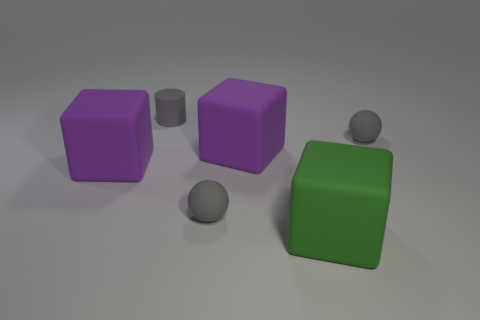Are the small ball that is on the left side of the big green thing and the green cube made of the same material?
Give a very brief answer. Yes. What is the material of the large purple thing that is right of the matte cube that is to the left of the small gray rubber cylinder?
Give a very brief answer. Rubber. What number of small rubber things have the same shape as the big green object?
Provide a short and direct response. 0. There is a gray rubber ball that is to the left of the cube that is right of the big purple object to the right of the rubber cylinder; what is its size?
Make the answer very short. Small. What number of yellow things are big matte blocks or tiny things?
Offer a very short reply. 0. Do the small gray object right of the green rubber cube and the green object have the same shape?
Make the answer very short. No. Are there more tiny rubber objects that are in front of the gray matte cylinder than small spheres?
Offer a terse response. No. How many other cylinders are the same size as the matte cylinder?
Your answer should be very brief. 0. What number of things are tiny gray matte cylinders or tiny gray objects that are to the right of the green rubber object?
Your answer should be very brief. 2. There is a cube that is right of the cylinder and behind the big green object; what is its color?
Provide a short and direct response. Purple. 